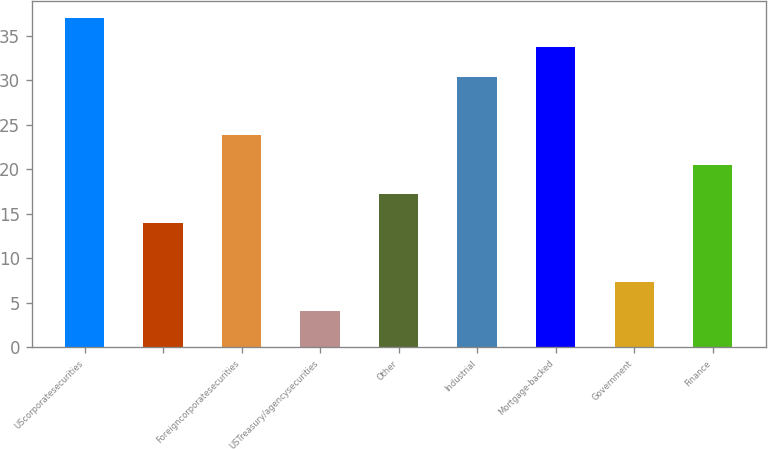Convert chart to OTSL. <chart><loc_0><loc_0><loc_500><loc_500><bar_chart><fcel>UScorporatesecurities<fcel>Unnamed: 1<fcel>Foreigncorporatesecurities<fcel>USTreasury/agencysecurities<fcel>Other<fcel>Industrial<fcel>Mortgage-backed<fcel>Government<fcel>Finance<nl><fcel>37<fcel>13.9<fcel>23.8<fcel>4<fcel>17.2<fcel>30.4<fcel>33.7<fcel>7.3<fcel>20.5<nl></chart> 